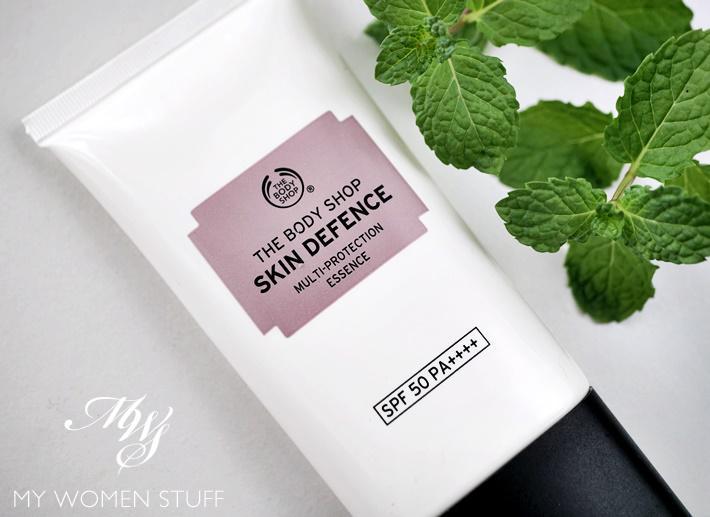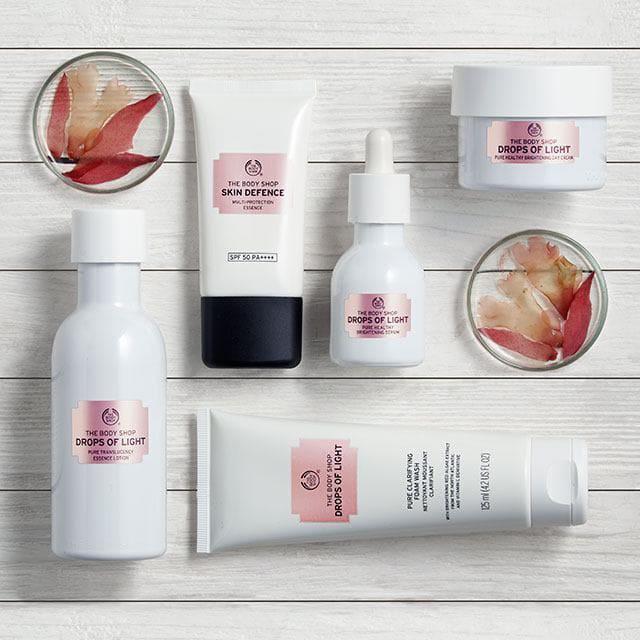The first image is the image on the left, the second image is the image on the right. Given the left and right images, does the statement "Both tubes shown are standing upright." hold true? Answer yes or no. No. 